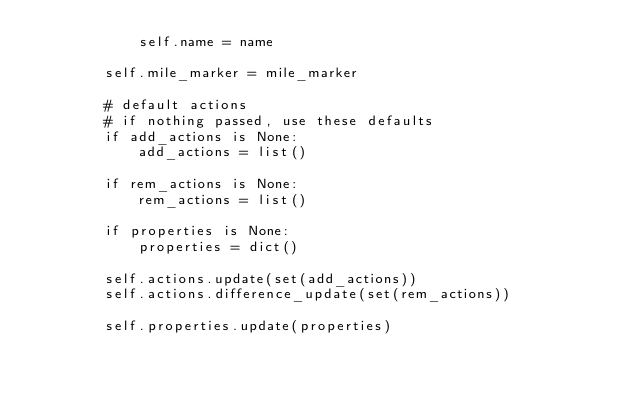<code> <loc_0><loc_0><loc_500><loc_500><_Python_>            self.name = name

        self.mile_marker = mile_marker

        # default actions
        # if nothing passed, use these defaults
        if add_actions is None:
            add_actions = list()

        if rem_actions is None:
            rem_actions = list()

        if properties is None:
            properties = dict()

        self.actions.update(set(add_actions))
        self.actions.difference_update(set(rem_actions))

        self.properties.update(properties)

</code> 